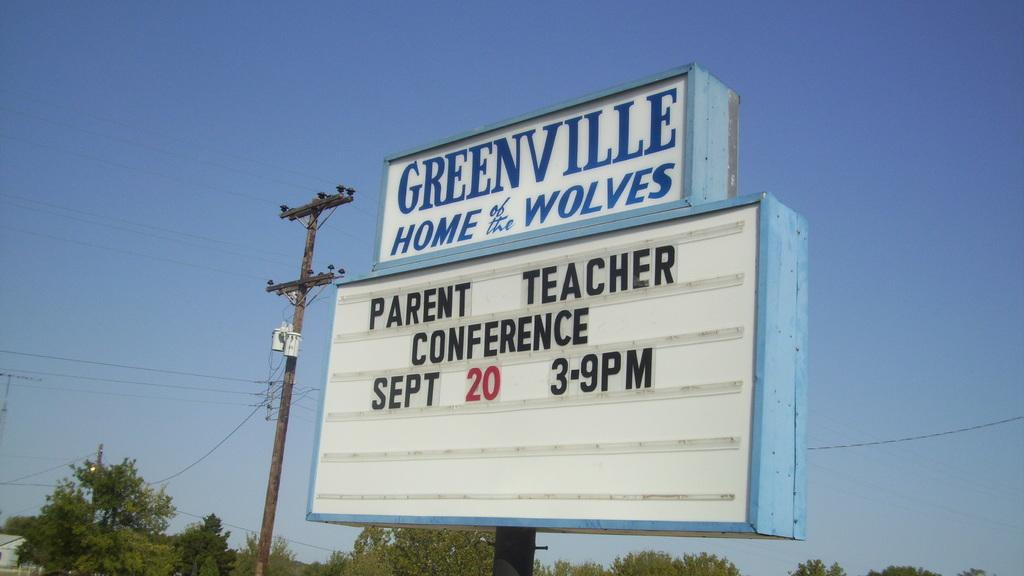<image>
Summarize the visual content of the image. A Greenville school signboard advertising a parent and teacher conference. 